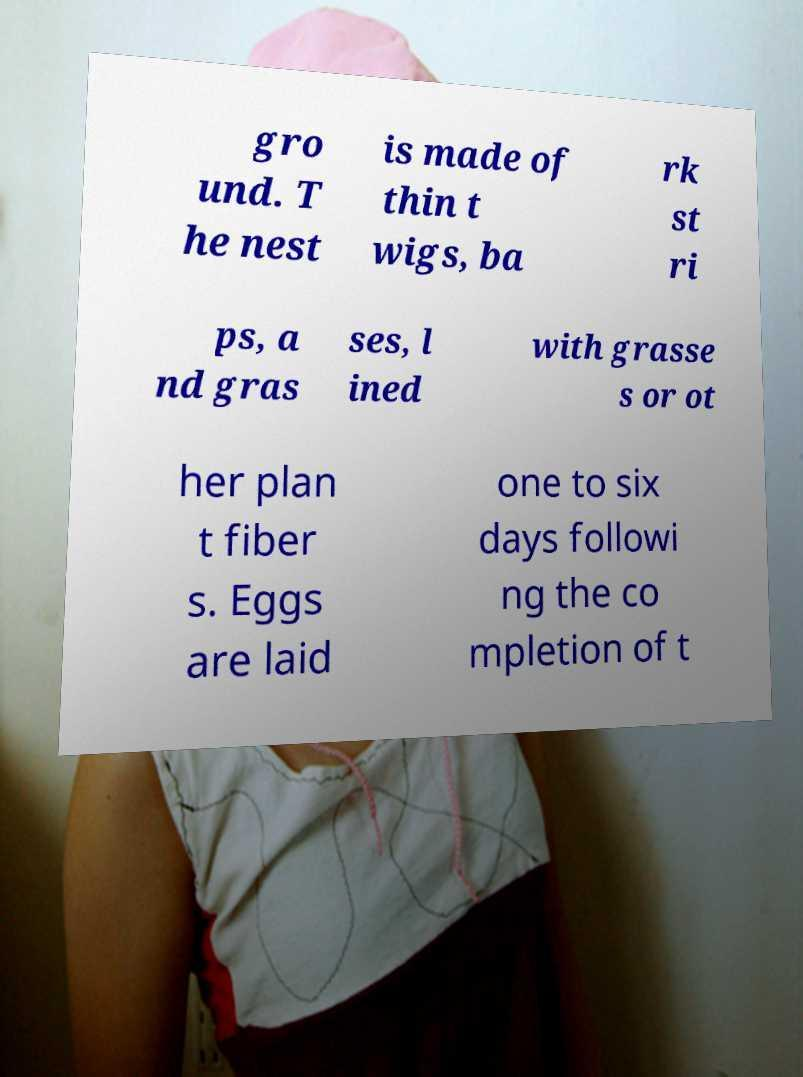Please read and relay the text visible in this image. What does it say? gro und. T he nest is made of thin t wigs, ba rk st ri ps, a nd gras ses, l ined with grasse s or ot her plan t fiber s. Eggs are laid one to six days followi ng the co mpletion of t 